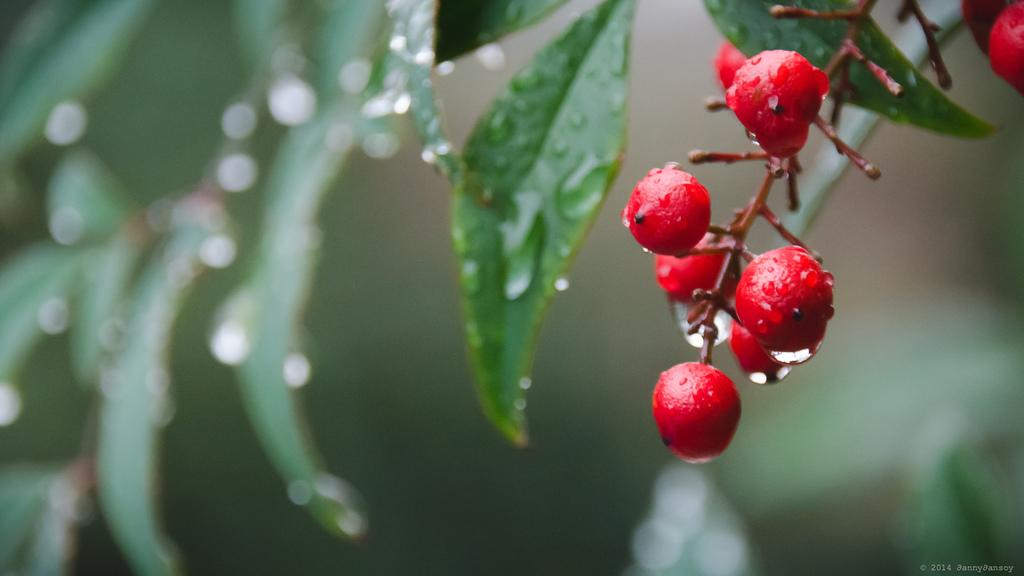What is the main subject of the image? The main subject of the image is cherries. Where are the cherries located in the image? The cherries are in the middle of the image. What can be seen in the background of the image? There are green leaves in the background of the image. What is the condition of the leaves in the image? There are droplets of water on the leaves. What verse can be heard recited by the cherries in the image? There is no verse being recited by the cherries in the image, as cherries do not have the ability to speak or recite verses. 